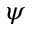<formula> <loc_0><loc_0><loc_500><loc_500>\psi</formula> 